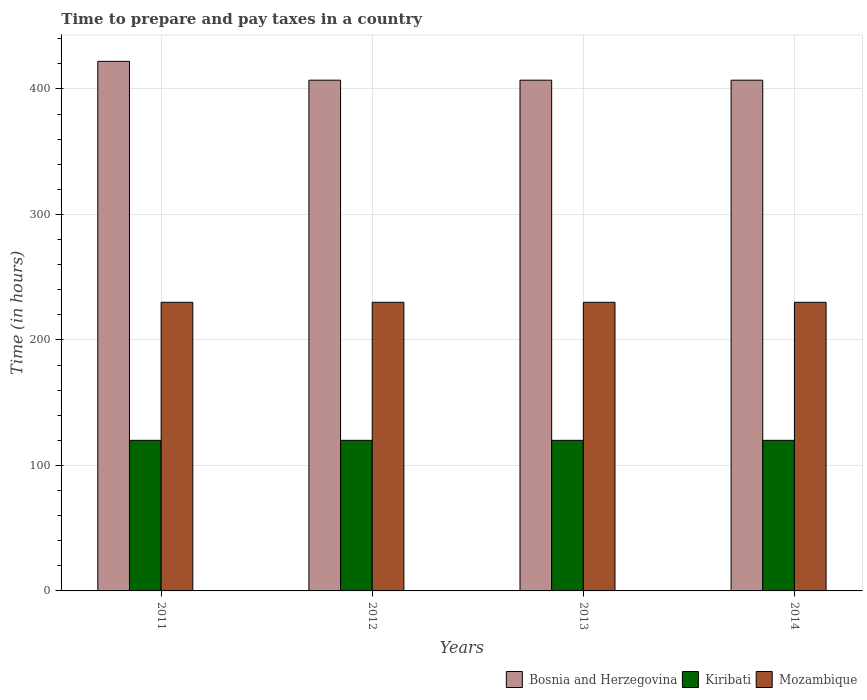How many different coloured bars are there?
Provide a short and direct response. 3. How many groups of bars are there?
Provide a succinct answer. 4. Are the number of bars per tick equal to the number of legend labels?
Your answer should be compact. Yes. Are the number of bars on each tick of the X-axis equal?
Make the answer very short. Yes. How many bars are there on the 3rd tick from the left?
Your answer should be very brief. 3. What is the label of the 3rd group of bars from the left?
Provide a succinct answer. 2013. In how many cases, is the number of bars for a given year not equal to the number of legend labels?
Offer a terse response. 0. What is the number of hours required to prepare and pay taxes in Mozambique in 2014?
Provide a short and direct response. 230. Across all years, what is the maximum number of hours required to prepare and pay taxes in Kiribati?
Make the answer very short. 120. Across all years, what is the minimum number of hours required to prepare and pay taxes in Mozambique?
Your answer should be very brief. 230. In which year was the number of hours required to prepare and pay taxes in Kiribati minimum?
Offer a very short reply. 2011. What is the total number of hours required to prepare and pay taxes in Mozambique in the graph?
Your response must be concise. 920. What is the difference between the number of hours required to prepare and pay taxes in Kiribati in 2012 and that in 2014?
Provide a succinct answer. 0. What is the difference between the number of hours required to prepare and pay taxes in Mozambique in 2011 and the number of hours required to prepare and pay taxes in Kiribati in 2013?
Make the answer very short. 110. What is the average number of hours required to prepare and pay taxes in Mozambique per year?
Your answer should be very brief. 230. In the year 2014, what is the difference between the number of hours required to prepare and pay taxes in Bosnia and Herzegovina and number of hours required to prepare and pay taxes in Kiribati?
Offer a very short reply. 287. What is the ratio of the number of hours required to prepare and pay taxes in Kiribati in 2012 to that in 2013?
Offer a terse response. 1. Is the number of hours required to prepare and pay taxes in Mozambique in 2012 less than that in 2014?
Make the answer very short. No. Is the difference between the number of hours required to prepare and pay taxes in Bosnia and Herzegovina in 2012 and 2013 greater than the difference between the number of hours required to prepare and pay taxes in Kiribati in 2012 and 2013?
Ensure brevity in your answer.  No. What is the difference between the highest and the lowest number of hours required to prepare and pay taxes in Kiribati?
Make the answer very short. 0. Is the sum of the number of hours required to prepare and pay taxes in Kiribati in 2011 and 2012 greater than the maximum number of hours required to prepare and pay taxes in Mozambique across all years?
Your answer should be compact. Yes. What does the 2nd bar from the left in 2014 represents?
Provide a succinct answer. Kiribati. What does the 3rd bar from the right in 2011 represents?
Provide a short and direct response. Bosnia and Herzegovina. How many bars are there?
Your response must be concise. 12. How are the legend labels stacked?
Ensure brevity in your answer.  Horizontal. What is the title of the graph?
Offer a very short reply. Time to prepare and pay taxes in a country. Does "Pacific island small states" appear as one of the legend labels in the graph?
Your response must be concise. No. What is the label or title of the X-axis?
Give a very brief answer. Years. What is the label or title of the Y-axis?
Your response must be concise. Time (in hours). What is the Time (in hours) of Bosnia and Herzegovina in 2011?
Keep it short and to the point. 422. What is the Time (in hours) of Kiribati in 2011?
Your answer should be compact. 120. What is the Time (in hours) of Mozambique in 2011?
Your answer should be very brief. 230. What is the Time (in hours) of Bosnia and Herzegovina in 2012?
Offer a very short reply. 407. What is the Time (in hours) in Kiribati in 2012?
Keep it short and to the point. 120. What is the Time (in hours) of Mozambique in 2012?
Ensure brevity in your answer.  230. What is the Time (in hours) of Bosnia and Herzegovina in 2013?
Offer a very short reply. 407. What is the Time (in hours) of Kiribati in 2013?
Ensure brevity in your answer.  120. What is the Time (in hours) of Mozambique in 2013?
Give a very brief answer. 230. What is the Time (in hours) in Bosnia and Herzegovina in 2014?
Ensure brevity in your answer.  407. What is the Time (in hours) in Kiribati in 2014?
Your answer should be very brief. 120. What is the Time (in hours) of Mozambique in 2014?
Make the answer very short. 230. Across all years, what is the maximum Time (in hours) in Bosnia and Herzegovina?
Your response must be concise. 422. Across all years, what is the maximum Time (in hours) of Kiribati?
Keep it short and to the point. 120. Across all years, what is the maximum Time (in hours) in Mozambique?
Provide a short and direct response. 230. Across all years, what is the minimum Time (in hours) of Bosnia and Herzegovina?
Provide a short and direct response. 407. Across all years, what is the minimum Time (in hours) of Kiribati?
Your answer should be very brief. 120. Across all years, what is the minimum Time (in hours) in Mozambique?
Provide a succinct answer. 230. What is the total Time (in hours) of Bosnia and Herzegovina in the graph?
Offer a very short reply. 1643. What is the total Time (in hours) of Kiribati in the graph?
Your answer should be very brief. 480. What is the total Time (in hours) of Mozambique in the graph?
Provide a short and direct response. 920. What is the difference between the Time (in hours) in Bosnia and Herzegovina in 2011 and that in 2012?
Your answer should be very brief. 15. What is the difference between the Time (in hours) in Kiribati in 2011 and that in 2012?
Keep it short and to the point. 0. What is the difference between the Time (in hours) in Mozambique in 2011 and that in 2013?
Give a very brief answer. 0. What is the difference between the Time (in hours) in Bosnia and Herzegovina in 2011 and that in 2014?
Provide a short and direct response. 15. What is the difference between the Time (in hours) of Bosnia and Herzegovina in 2012 and that in 2013?
Your answer should be compact. 0. What is the difference between the Time (in hours) in Bosnia and Herzegovina in 2012 and that in 2014?
Ensure brevity in your answer.  0. What is the difference between the Time (in hours) of Kiribati in 2013 and that in 2014?
Ensure brevity in your answer.  0. What is the difference between the Time (in hours) of Mozambique in 2013 and that in 2014?
Give a very brief answer. 0. What is the difference between the Time (in hours) in Bosnia and Herzegovina in 2011 and the Time (in hours) in Kiribati in 2012?
Your response must be concise. 302. What is the difference between the Time (in hours) of Bosnia and Herzegovina in 2011 and the Time (in hours) of Mozambique in 2012?
Offer a terse response. 192. What is the difference between the Time (in hours) in Kiribati in 2011 and the Time (in hours) in Mozambique in 2012?
Provide a succinct answer. -110. What is the difference between the Time (in hours) in Bosnia and Herzegovina in 2011 and the Time (in hours) in Kiribati in 2013?
Provide a succinct answer. 302. What is the difference between the Time (in hours) of Bosnia and Herzegovina in 2011 and the Time (in hours) of Mozambique in 2013?
Provide a succinct answer. 192. What is the difference between the Time (in hours) of Kiribati in 2011 and the Time (in hours) of Mozambique in 2013?
Your response must be concise. -110. What is the difference between the Time (in hours) in Bosnia and Herzegovina in 2011 and the Time (in hours) in Kiribati in 2014?
Offer a very short reply. 302. What is the difference between the Time (in hours) of Bosnia and Herzegovina in 2011 and the Time (in hours) of Mozambique in 2014?
Offer a very short reply. 192. What is the difference between the Time (in hours) in Kiribati in 2011 and the Time (in hours) in Mozambique in 2014?
Provide a short and direct response. -110. What is the difference between the Time (in hours) in Bosnia and Herzegovina in 2012 and the Time (in hours) in Kiribati in 2013?
Your answer should be compact. 287. What is the difference between the Time (in hours) in Bosnia and Herzegovina in 2012 and the Time (in hours) in Mozambique in 2013?
Provide a short and direct response. 177. What is the difference between the Time (in hours) of Kiribati in 2012 and the Time (in hours) of Mozambique in 2013?
Your answer should be compact. -110. What is the difference between the Time (in hours) in Bosnia and Herzegovina in 2012 and the Time (in hours) in Kiribati in 2014?
Your answer should be very brief. 287. What is the difference between the Time (in hours) in Bosnia and Herzegovina in 2012 and the Time (in hours) in Mozambique in 2014?
Ensure brevity in your answer.  177. What is the difference between the Time (in hours) of Kiribati in 2012 and the Time (in hours) of Mozambique in 2014?
Provide a succinct answer. -110. What is the difference between the Time (in hours) in Bosnia and Herzegovina in 2013 and the Time (in hours) in Kiribati in 2014?
Your answer should be very brief. 287. What is the difference between the Time (in hours) of Bosnia and Herzegovina in 2013 and the Time (in hours) of Mozambique in 2014?
Your answer should be very brief. 177. What is the difference between the Time (in hours) of Kiribati in 2013 and the Time (in hours) of Mozambique in 2014?
Your answer should be very brief. -110. What is the average Time (in hours) in Bosnia and Herzegovina per year?
Offer a very short reply. 410.75. What is the average Time (in hours) of Kiribati per year?
Offer a terse response. 120. What is the average Time (in hours) in Mozambique per year?
Offer a terse response. 230. In the year 2011, what is the difference between the Time (in hours) in Bosnia and Herzegovina and Time (in hours) in Kiribati?
Ensure brevity in your answer.  302. In the year 2011, what is the difference between the Time (in hours) of Bosnia and Herzegovina and Time (in hours) of Mozambique?
Ensure brevity in your answer.  192. In the year 2011, what is the difference between the Time (in hours) in Kiribati and Time (in hours) in Mozambique?
Offer a very short reply. -110. In the year 2012, what is the difference between the Time (in hours) in Bosnia and Herzegovina and Time (in hours) in Kiribati?
Give a very brief answer. 287. In the year 2012, what is the difference between the Time (in hours) in Bosnia and Herzegovina and Time (in hours) in Mozambique?
Keep it short and to the point. 177. In the year 2012, what is the difference between the Time (in hours) in Kiribati and Time (in hours) in Mozambique?
Offer a very short reply. -110. In the year 2013, what is the difference between the Time (in hours) of Bosnia and Herzegovina and Time (in hours) of Kiribati?
Offer a very short reply. 287. In the year 2013, what is the difference between the Time (in hours) of Bosnia and Herzegovina and Time (in hours) of Mozambique?
Make the answer very short. 177. In the year 2013, what is the difference between the Time (in hours) in Kiribati and Time (in hours) in Mozambique?
Your answer should be compact. -110. In the year 2014, what is the difference between the Time (in hours) in Bosnia and Herzegovina and Time (in hours) in Kiribati?
Ensure brevity in your answer.  287. In the year 2014, what is the difference between the Time (in hours) in Bosnia and Herzegovina and Time (in hours) in Mozambique?
Offer a very short reply. 177. In the year 2014, what is the difference between the Time (in hours) in Kiribati and Time (in hours) in Mozambique?
Make the answer very short. -110. What is the ratio of the Time (in hours) in Bosnia and Herzegovina in 2011 to that in 2012?
Offer a very short reply. 1.04. What is the ratio of the Time (in hours) of Kiribati in 2011 to that in 2012?
Offer a very short reply. 1. What is the ratio of the Time (in hours) in Bosnia and Herzegovina in 2011 to that in 2013?
Your answer should be very brief. 1.04. What is the ratio of the Time (in hours) in Mozambique in 2011 to that in 2013?
Provide a succinct answer. 1. What is the ratio of the Time (in hours) in Bosnia and Herzegovina in 2011 to that in 2014?
Provide a short and direct response. 1.04. What is the ratio of the Time (in hours) in Bosnia and Herzegovina in 2012 to that in 2013?
Your response must be concise. 1. What is the ratio of the Time (in hours) of Mozambique in 2012 to that in 2013?
Offer a terse response. 1. What is the ratio of the Time (in hours) of Bosnia and Herzegovina in 2012 to that in 2014?
Give a very brief answer. 1. What is the ratio of the Time (in hours) of Mozambique in 2012 to that in 2014?
Keep it short and to the point. 1. What is the ratio of the Time (in hours) in Bosnia and Herzegovina in 2013 to that in 2014?
Keep it short and to the point. 1. What is the difference between the highest and the lowest Time (in hours) of Bosnia and Herzegovina?
Provide a short and direct response. 15. What is the difference between the highest and the lowest Time (in hours) of Mozambique?
Ensure brevity in your answer.  0. 